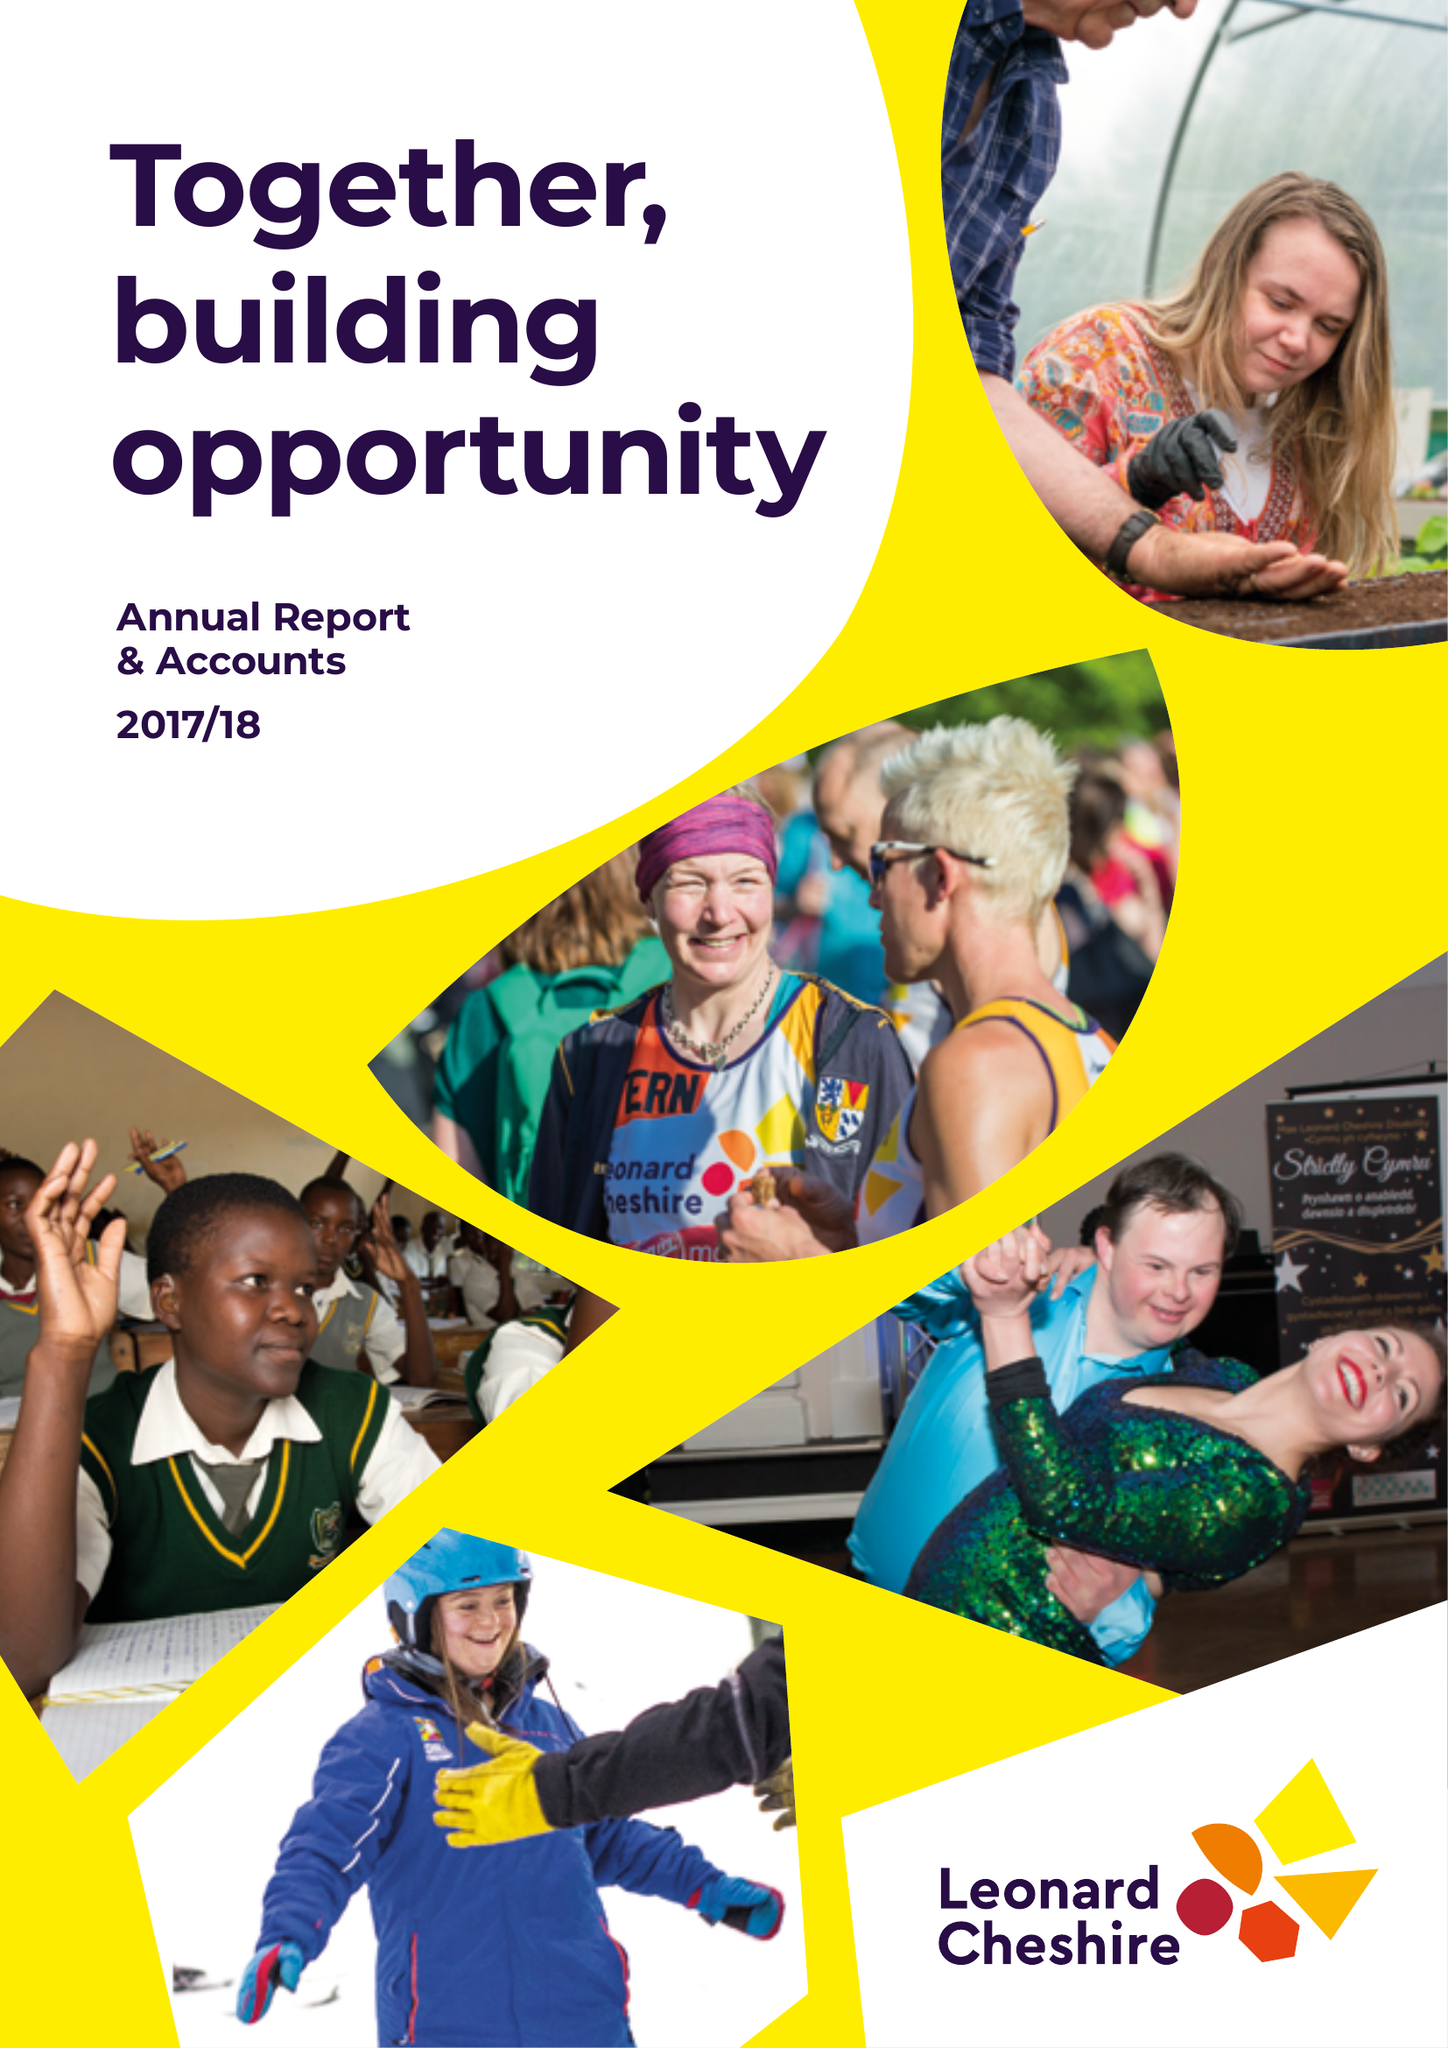What is the value for the charity_name?
Answer the question using a single word or phrase. Leonard Cheshire Disability Ltd. 